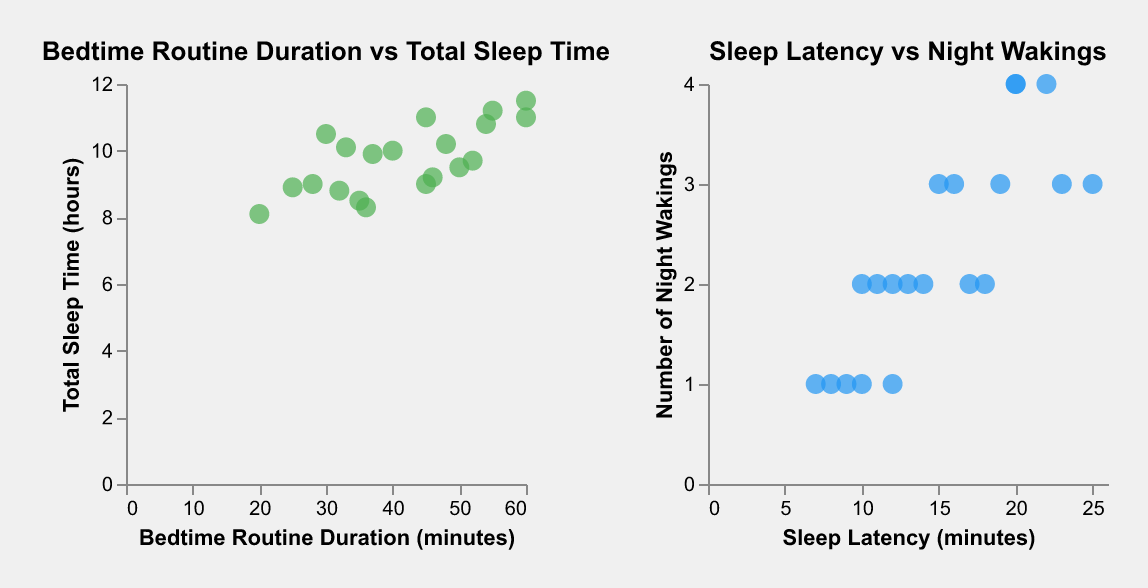What is the title of the left subplot? The title of the left subplot is displayed at the top of the subplot. From the data and code provided, it is "Bedtime Routine Duration vs Total Sleep Time".
Answer: Bedtime Routine Duration vs Total Sleep Time How many data points are shown in the right subplot? Each data point corresponds to one entry in the dataset and is represented by a point on the plot. There are 20 entries in the provided data.
Answer: 20 What is the color of the data points in the left subplot? The data points' color on the left plot is specified in the code as "#4CAF50", which is a shade of green.
Answer: Green What is the average number of night wakings in the right subplot? To find the average number of night wakings, sum all the night wakings and divide by the number of data points. 2+3+1+2+4+2+1+3+2+4+2+1+3+2+1+3+4+2+1+3 = 44. The average is 44/20 = 2.2.
Answer: 2.2 Does a longer bedtime routine generally result in more or fewer night wakings based on the information in the subplots? The right subplot, "Sleep Latency vs Night Wakings", does not directly convey this information, so you need to look at the left subplot and the data for any patterns in bedtime routine duration. Typically, longer bedtime routines in the dataset do not correlate directly with the number of night wakings as other factors are involved.
Answer: The relationship is not directly clear Which age group has the shortest sleep latency? Examine the data points corresponding to different ages to identify the shortest sleep latency. According to the data, the shortest sleep latency (7 minutes) is observed at 11 months.
Answer: 11 months Is there any correlation between bedtime routine duration and total sleep time shown in the left subplot? In the left subplot, "Bedtime Routine Duration vs Total Sleep Time," by analyzing the general trend of the points, longer bedtime routines often correlate with more total sleep time, though exceptions exist.
Answer: Yes, generally, longer routines correlate with more sleep time Which data points indicate an infant with more than 11 hours of sleep and what is their bedtime routine duration? Look for data points on the left subplot where "Total Sleep Time (hours)" is greater than 11. The corresponding bedtime routine durations are 55 for 11.2 hours and 60 for 11.5 hours.
Answer: 55 and 60 minutes 